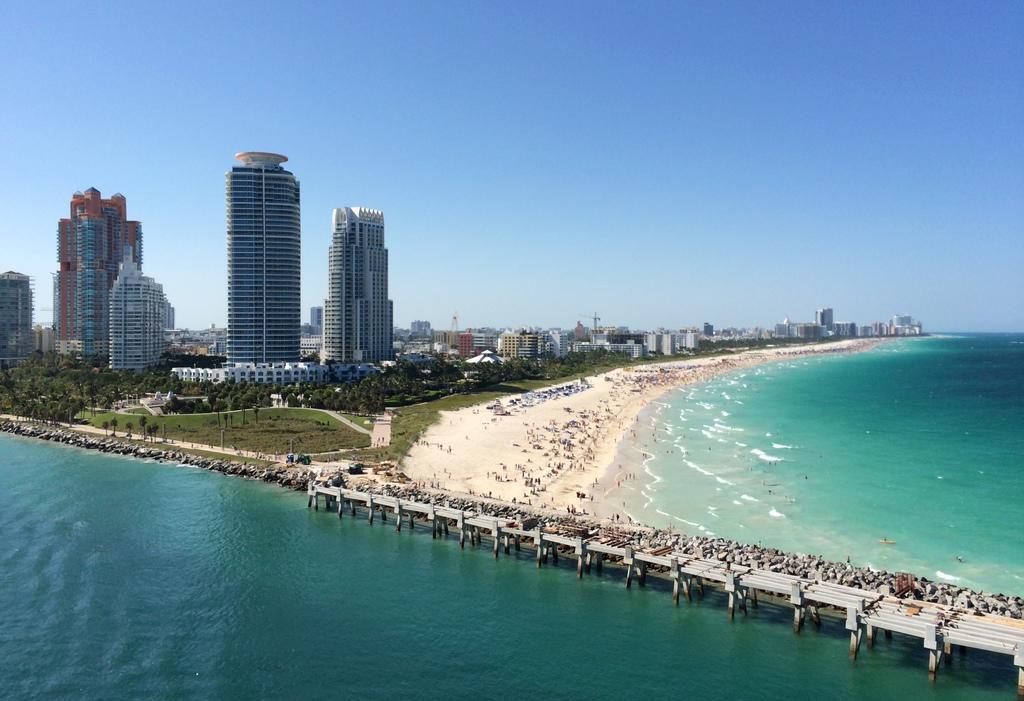What is present in the image that represents a natural element? There is water in the image. What type of structure can be seen in the image? There is a bridge in the image. Can you describe the people in the image? There is a group of people in the image. What type of buildings are visible in the image? There are skyscrapers in the image. What type of vegetation is present in the image? There are trees in the image. What type of transportation infrastructure is visible in the image? There are roads in the image. What part of the natural environment is visible in the image? The sky is visible in the image. Can you tell me how many roses are being cooked by the people in the image? There are no roses or cooking activities present in the image. What type of humor can be observed in the image? There is no humor present in the image; it is a scene of a bridge, water, skyscrapers, trees, roads, and a group of people. 